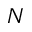<formula> <loc_0><loc_0><loc_500><loc_500>N</formula> 